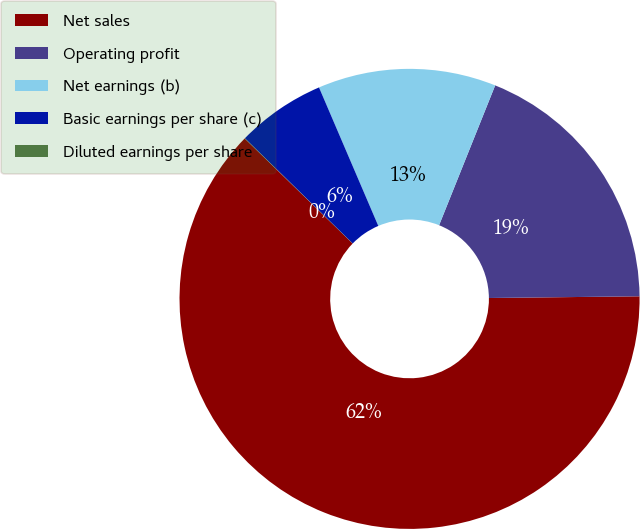Convert chart to OTSL. <chart><loc_0><loc_0><loc_500><loc_500><pie_chart><fcel>Net sales<fcel>Operating profit<fcel>Net earnings (b)<fcel>Basic earnings per share (c)<fcel>Diluted earnings per share<nl><fcel>62.46%<fcel>18.75%<fcel>12.51%<fcel>6.26%<fcel>0.02%<nl></chart> 